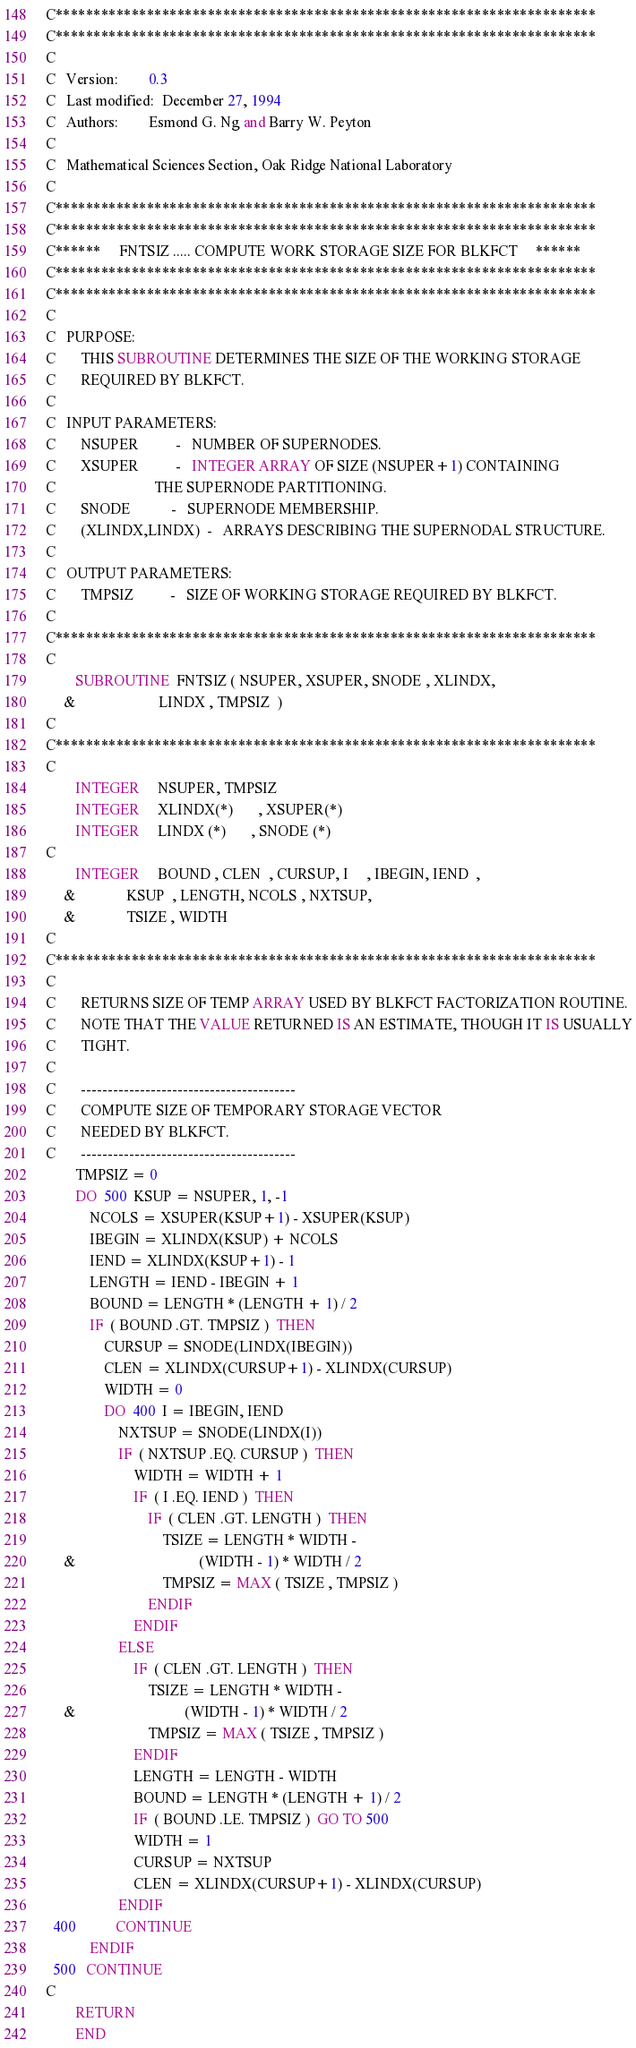<code> <loc_0><loc_0><loc_500><loc_500><_FORTRAN_>C***********************************************************************
C***********************************************************************
C
C   Version:        0.3
C   Last modified:  December 27, 1994
C   Authors:        Esmond G. Ng and Barry W. Peyton
C
C   Mathematical Sciences Section, Oak Ridge National Laboratory
C
C***********************************************************************
C***********************************************************************
C******     FNTSIZ ..... COMPUTE WORK STORAGE SIZE FOR BLKFCT     ******
C***********************************************************************
C***********************************************************************
C
C   PURPOSE:
C       THIS SUBROUTINE DETERMINES THE SIZE OF THE WORKING STORAGE
C       REQUIRED BY BLKFCT.
C
C   INPUT PARAMETERS:
C       NSUPER          -   NUMBER OF SUPERNODES.
C       XSUPER          -   INTEGER ARRAY OF SIZE (NSUPER+1) CONTAINING
C                           THE SUPERNODE PARTITIONING.
C       SNODE           -   SUPERNODE MEMBERSHIP.
C       (XLINDX,LINDX)  -   ARRAYS DESCRIBING THE SUPERNODAL STRUCTURE.
C
C   OUTPUT PARAMETERS:
C       TMPSIZ          -   SIZE OF WORKING STORAGE REQUIRED BY BLKFCT.
C
C***********************************************************************
C
        SUBROUTINE  FNTSIZ ( NSUPER, XSUPER, SNODE , XLINDX, 
     &                       LINDX , TMPSIZ  )
C
C***********************************************************************
C
        INTEGER     NSUPER, TMPSIZ
        INTEGER     XLINDX(*)       , XSUPER(*)
        INTEGER     LINDX (*)       , SNODE (*)
C
        INTEGER     BOUND , CLEN  , CURSUP, I     , IBEGIN, IEND  , 
     &              KSUP  , LENGTH, NCOLS , NXTSUP, 
     &              TSIZE , WIDTH
C
C***********************************************************************
C
C       RETURNS SIZE OF TEMP ARRAY USED BY BLKFCT FACTORIZATION ROUTINE.
C       NOTE THAT THE VALUE RETURNED IS AN ESTIMATE, THOUGH IT IS USUALLY
C       TIGHT.
C
C       ----------------------------------------
C       COMPUTE SIZE OF TEMPORARY STORAGE VECTOR
C       NEEDED BY BLKFCT.
C       ----------------------------------------
        TMPSIZ = 0
        DO  500  KSUP = NSUPER, 1, -1
            NCOLS = XSUPER(KSUP+1) - XSUPER(KSUP)
            IBEGIN = XLINDX(KSUP) + NCOLS
            IEND = XLINDX(KSUP+1) - 1
            LENGTH = IEND - IBEGIN + 1
            BOUND = LENGTH * (LENGTH + 1) / 2
            IF  ( BOUND .GT. TMPSIZ )  THEN
                CURSUP = SNODE(LINDX(IBEGIN))
                CLEN = XLINDX(CURSUP+1) - XLINDX(CURSUP)
                WIDTH = 0
                DO  400  I = IBEGIN, IEND
                    NXTSUP = SNODE(LINDX(I))
                    IF  ( NXTSUP .EQ. CURSUP )  THEN
                        WIDTH = WIDTH + 1
                        IF  ( I .EQ. IEND )  THEN
                            IF  ( CLEN .GT. LENGTH )  THEN
                                TSIZE = LENGTH * WIDTH - 
     &                                  (WIDTH - 1) * WIDTH / 2
                                TMPSIZ = MAX ( TSIZE , TMPSIZ )
                            ENDIF
                        ENDIF
                    ELSE
                        IF  ( CLEN .GT. LENGTH )  THEN
                            TSIZE = LENGTH * WIDTH - 
     &                              (WIDTH - 1) * WIDTH / 2
                            TMPSIZ = MAX ( TSIZE , TMPSIZ )
                        ENDIF
                        LENGTH = LENGTH - WIDTH
                        BOUND = LENGTH * (LENGTH + 1) / 2
                        IF  ( BOUND .LE. TMPSIZ )  GO TO 500
                        WIDTH = 1
                        CURSUP = NXTSUP
                        CLEN = XLINDX(CURSUP+1) - XLINDX(CURSUP)
                    ENDIF
  400           CONTINUE
            ENDIF
  500   CONTINUE
C
        RETURN
        END
</code> 